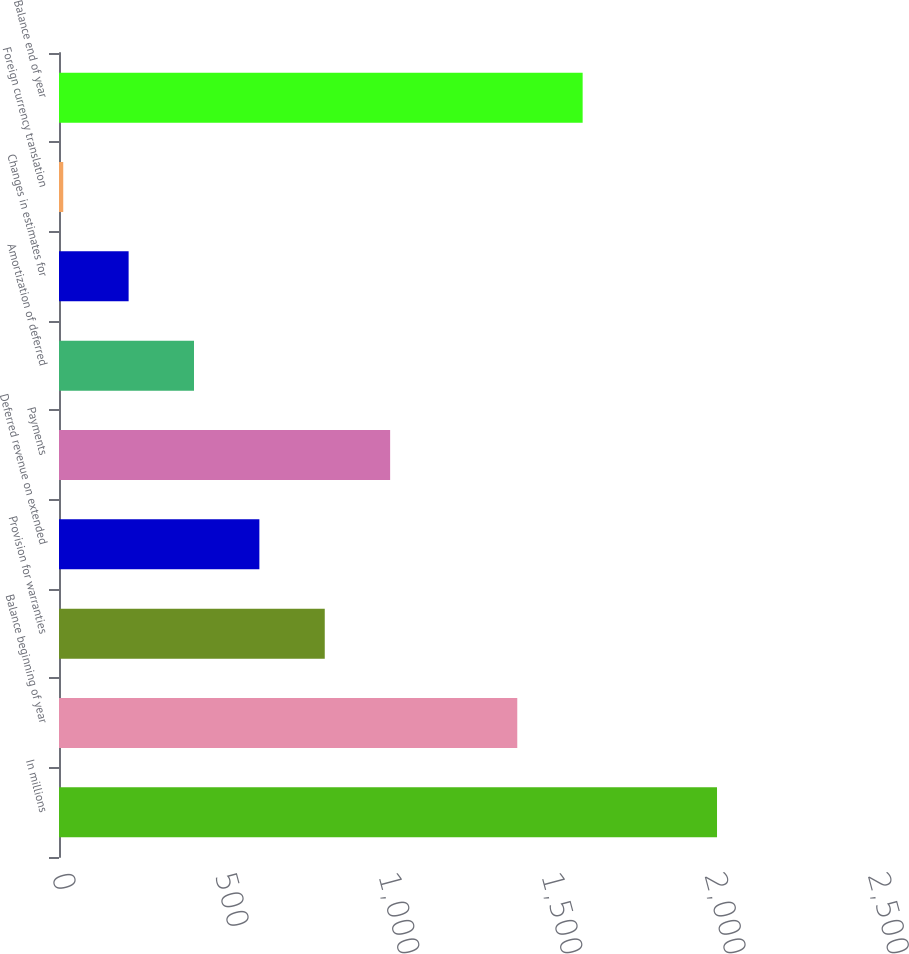Convert chart to OTSL. <chart><loc_0><loc_0><loc_500><loc_500><bar_chart><fcel>In millions<fcel>Balance beginning of year<fcel>Provision for warranties<fcel>Deferred revenue on extended<fcel>Payments<fcel>Amortization of deferred<fcel>Changes in estimates for<fcel>Foreign currency translation<fcel>Balance end of year<nl><fcel>2016<fcel>1404<fcel>814.2<fcel>613.9<fcel>1014.5<fcel>413.6<fcel>213.3<fcel>13<fcel>1604.3<nl></chart> 